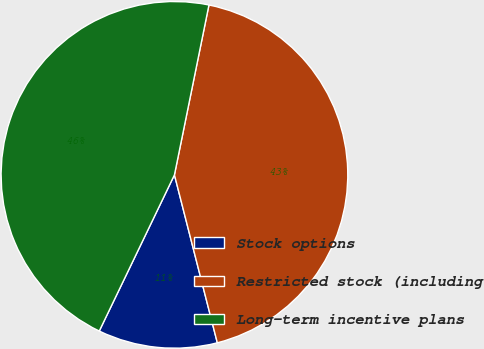Convert chart. <chart><loc_0><loc_0><loc_500><loc_500><pie_chart><fcel>Stock options<fcel>Restricted stock (including<fcel>Long-term incentive plans<nl><fcel>11.12%<fcel>42.83%<fcel>46.05%<nl></chart> 